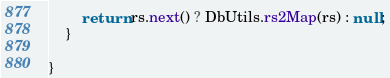Convert code to text. <code><loc_0><loc_0><loc_500><loc_500><_Java_>		return rs.next() ? DbUtils.rs2Map(rs) : null;
	}

}
</code> 